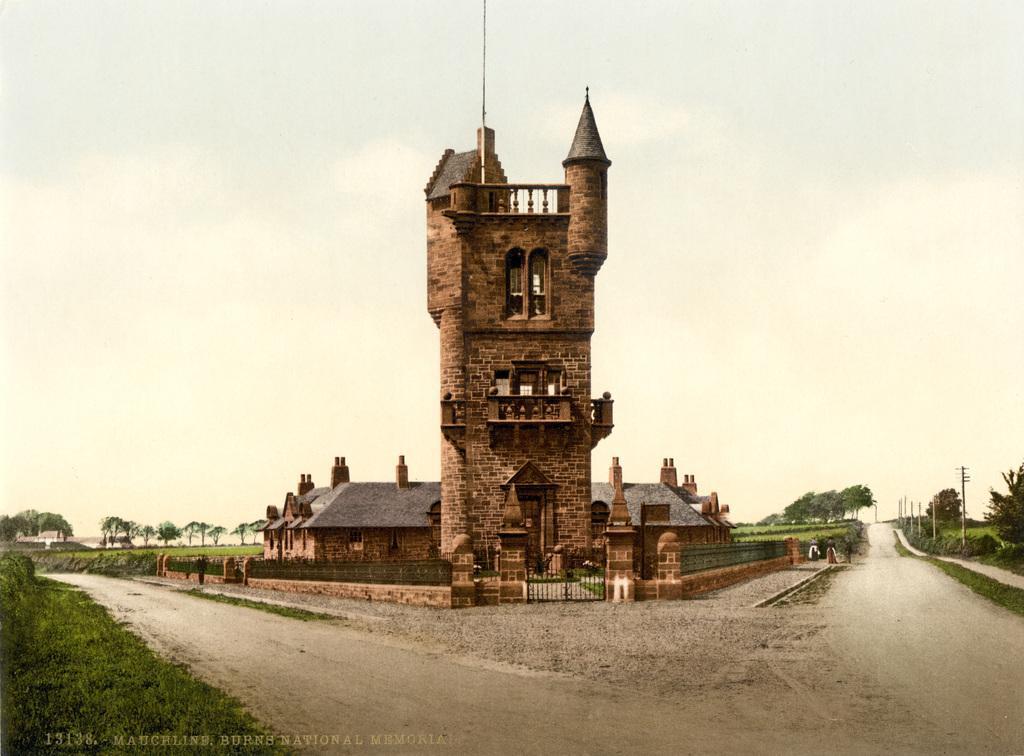Describe this image in one or two sentences. As we can see in the image there are buildings, gate, current polls, plants and trees. On the top there is sky. 